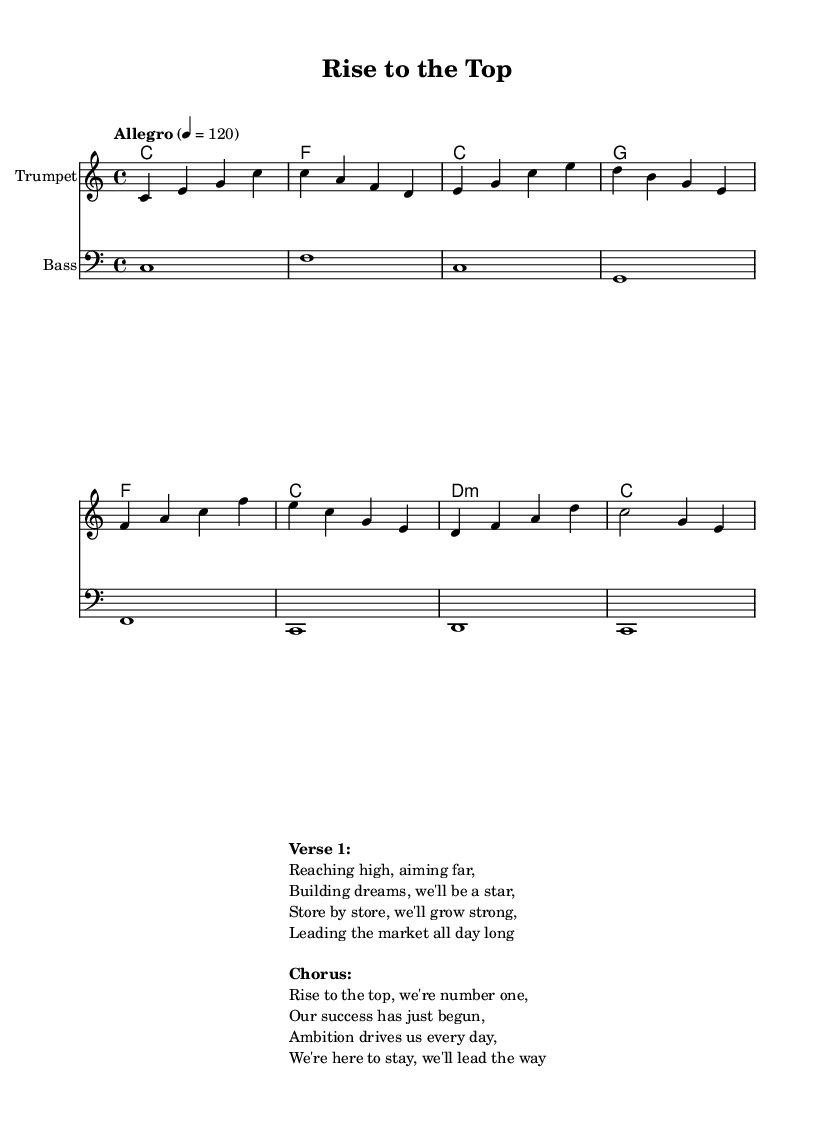What is the key signature of this music? The key signature is indicated at the beginning of the score and shows no sharps or flats, which identifies it as C major.
Answer: C major What is the time signature? The time signature is displayed at the start of the score and shows a four over four notation, meaning there are four beats in each measure and the quarter note gets one beat.
Answer: 4/4 What is the tempo marking for this piece? The tempo marking, found in the score, specifies a speed of "Allegro" with a metronome marking of 120 beats per minute, indicating a fast and lively pace for the performance.
Answer: Allegro, 120 Name the instruments featured in the score. The score includes a melody line for the Trumpet and a bass line, which is indicated in the staff names at the beginning of their respective staves.
Answer: Trumpet, Bass How many measures are in the melody? By counting the individual measures in the melody section, we find that there are a total of eight measures represented.
Answer: 8 What is the first line of the verse? The lyrics for the verse are displayed in the markup section of the score, where the first line is clearly stated as "Reaching high, aiming far," providing a positive and ambitious sentiment.
Answer: Reaching high, aiming far In what context is this music intended to be used? This music is structured as a corporate anthem, celebrating success and ambition, focusing on growth and leadership in the market, as indicated by the lyrics and overall theme.
Answer: Corporate anthem 